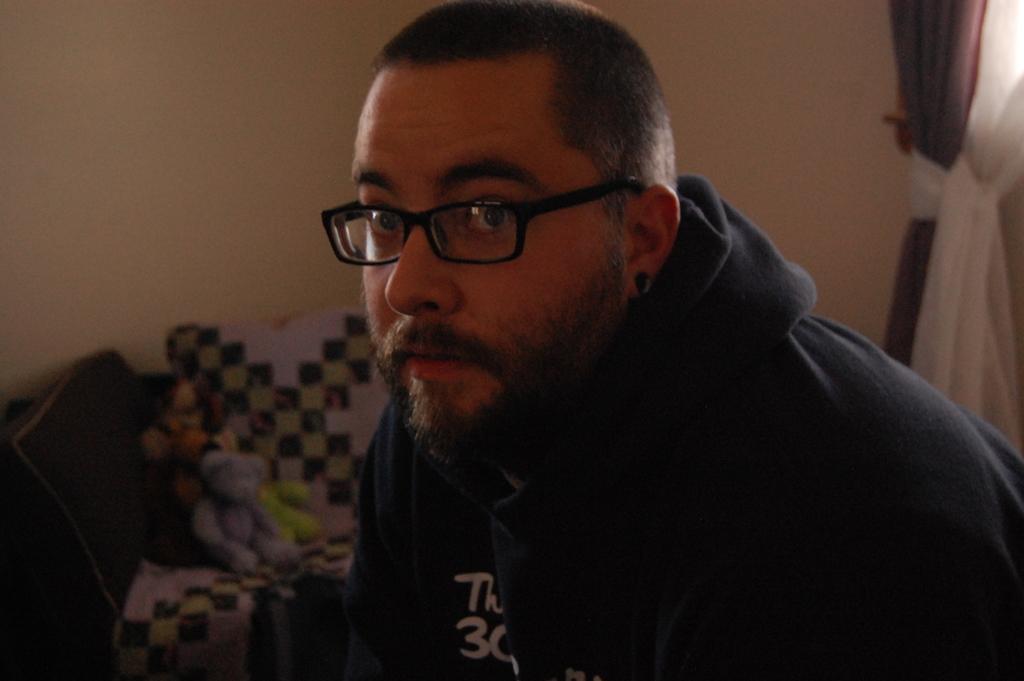How would you summarize this image in a sentence or two? In this picture I can see a man is wearing sunglasses, spectacles and I can see few toys on the chair and I can see curtain on the right side and a wall in the background. 